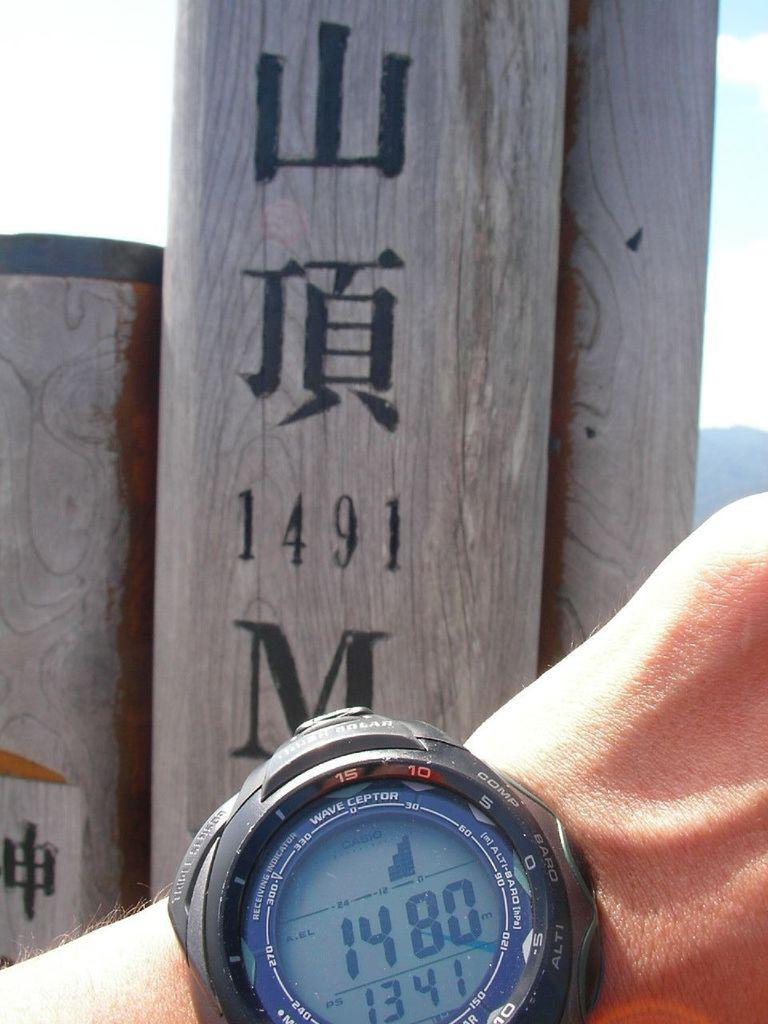<image>
Create a compact narrative representing the image presented. A Waveceptor watch that reads 1480 in front of a sign that says 1491. 